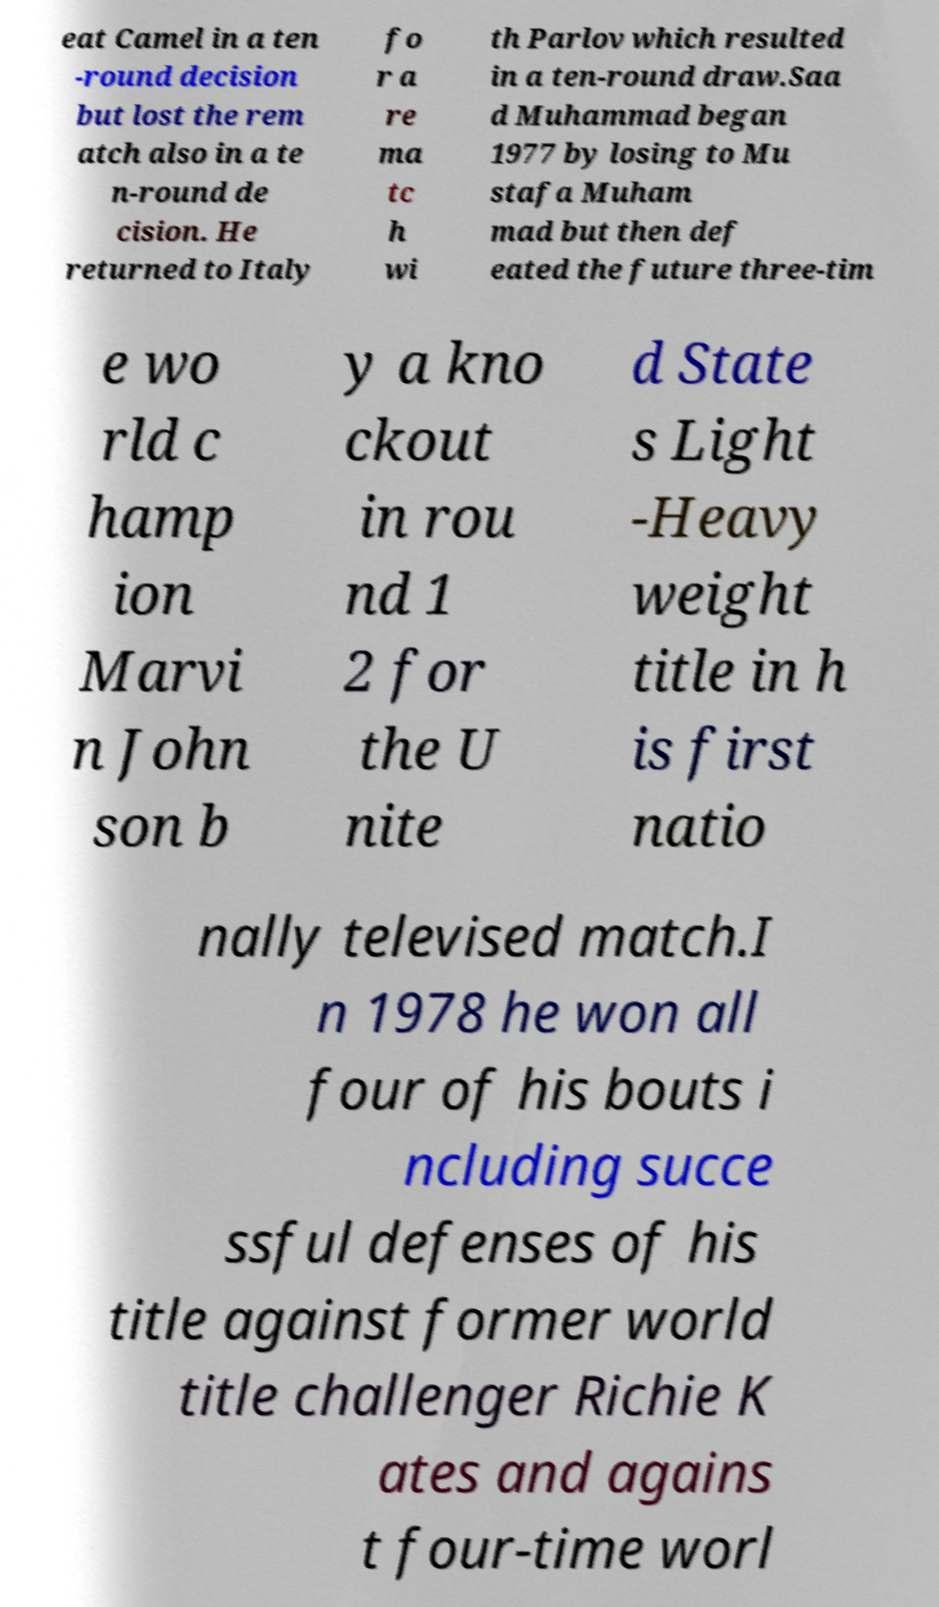Could you extract and type out the text from this image? eat Camel in a ten -round decision but lost the rem atch also in a te n-round de cision. He returned to Italy fo r a re ma tc h wi th Parlov which resulted in a ten-round draw.Saa d Muhammad began 1977 by losing to Mu stafa Muham mad but then def eated the future three-tim e wo rld c hamp ion Marvi n John son b y a kno ckout in rou nd 1 2 for the U nite d State s Light -Heavy weight title in h is first natio nally televised match.I n 1978 he won all four of his bouts i ncluding succe ssful defenses of his title against former world title challenger Richie K ates and agains t four-time worl 